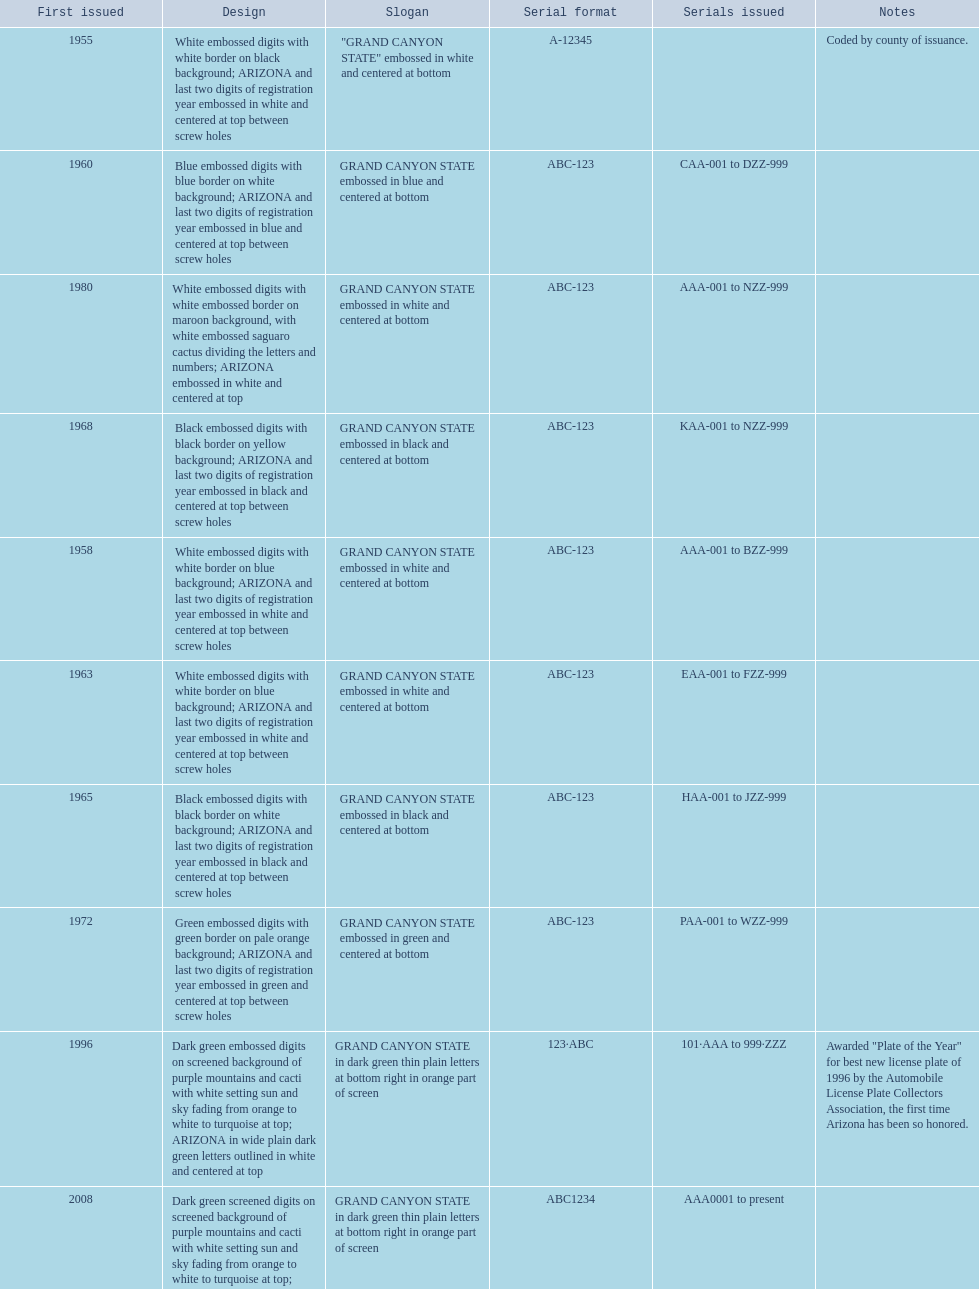What was year was the first arizona license plate made? 1955. 